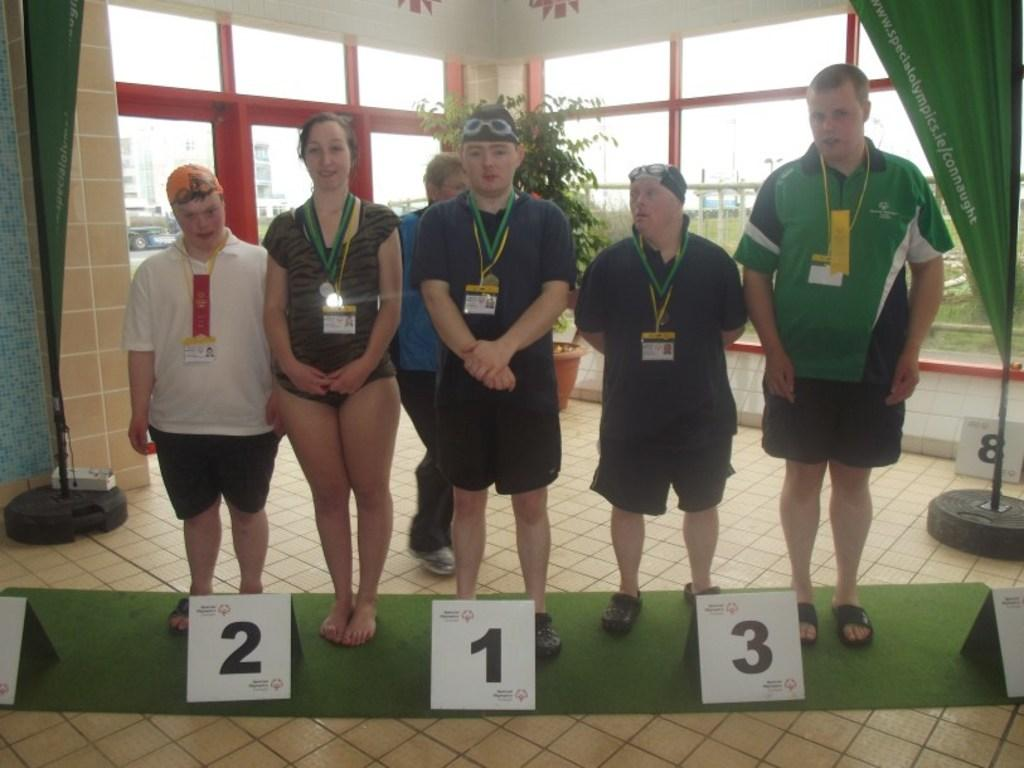What is the main subject of the image? The main subject of the image is a group of people. How are the people arranged in the image? The people are standing in a line. What additional detail can be observed about the people in the image? Numbers have been allotted to the people. What type of blade can be seen in the hands of the people in the image? There is no blade present in the image; the people are simply standing in a line with numbers allotted to them. 